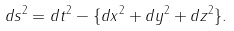<formula> <loc_0><loc_0><loc_500><loc_500>d s ^ { 2 } = d t ^ { 2 } - \{ d x ^ { 2 } + d y ^ { 2 } + d z ^ { 2 } \} .</formula> 